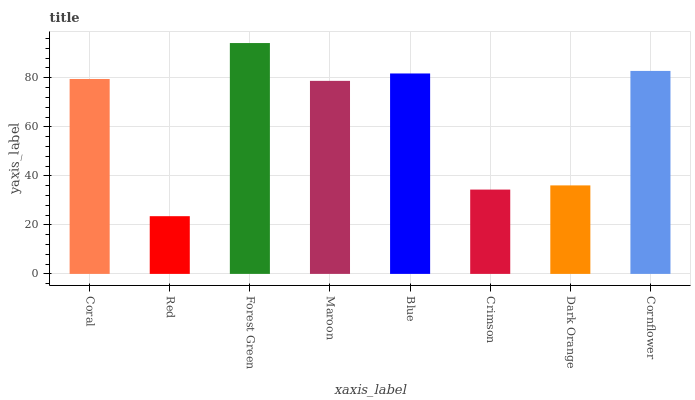Is Red the minimum?
Answer yes or no. Yes. Is Forest Green the maximum?
Answer yes or no. Yes. Is Forest Green the minimum?
Answer yes or no. No. Is Red the maximum?
Answer yes or no. No. Is Forest Green greater than Red?
Answer yes or no. Yes. Is Red less than Forest Green?
Answer yes or no. Yes. Is Red greater than Forest Green?
Answer yes or no. No. Is Forest Green less than Red?
Answer yes or no. No. Is Coral the high median?
Answer yes or no. Yes. Is Maroon the low median?
Answer yes or no. Yes. Is Cornflower the high median?
Answer yes or no. No. Is Red the low median?
Answer yes or no. No. 